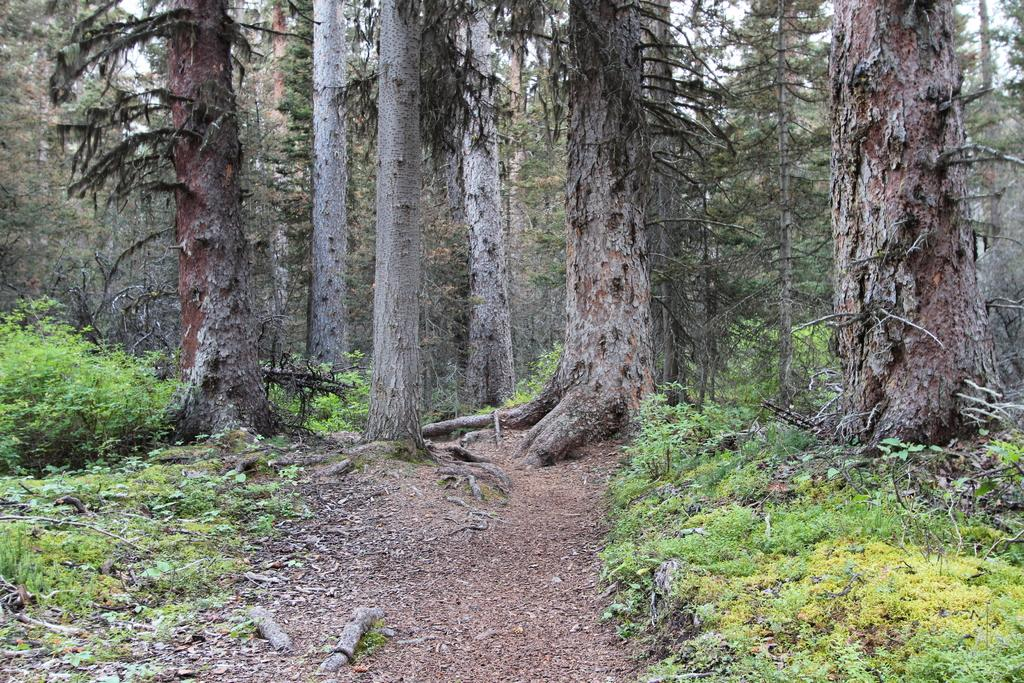What type of forest is depicted in the image? The image contains a spruce-fir forest. What are the main tree species found in this type of forest? The main tree species in a spruce-fir forest are spruce and fir trees. Can you describe the overall appearance of the forest in the image? The forest appears to be dense and green, with tall trees and possibly some undergrowth. What date is marked on the calendar hanging from a tree in the image? There is no calendar present in the image; it is a spruce-fir forest with no visible man-made objects. 